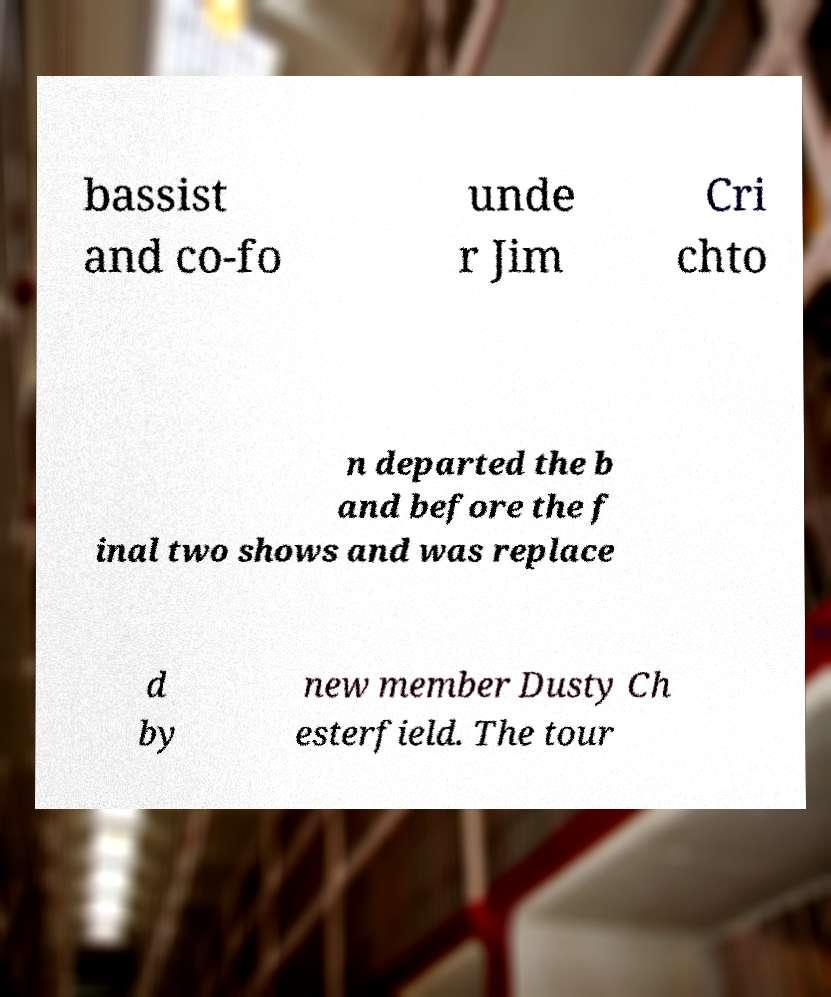Can you accurately transcribe the text from the provided image for me? bassist and co-fo unde r Jim Cri chto n departed the b and before the f inal two shows and was replace d by new member Dusty Ch esterfield. The tour 